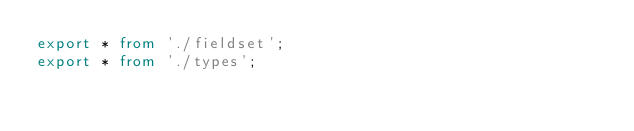<code> <loc_0><loc_0><loc_500><loc_500><_TypeScript_>export * from './fieldset';
export * from './types';
</code> 